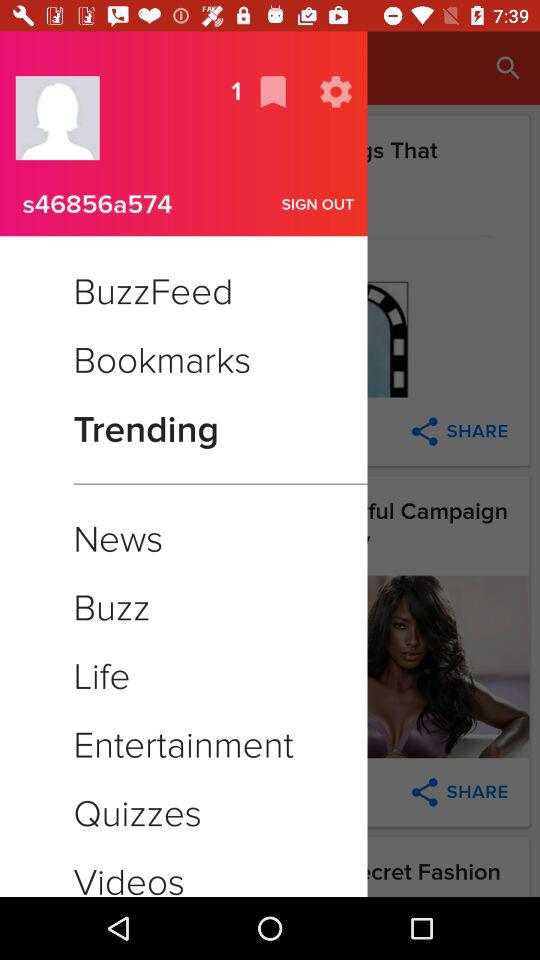How many new notifications?
When the provided information is insufficient, respond with <no answer>. <no answer> 